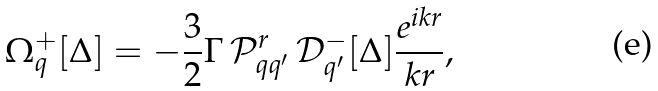<formula> <loc_0><loc_0><loc_500><loc_500>\Omega ^ { + } _ { q } [ \Delta ] = - \frac { 3 } { 2 } \Gamma \, \mathcal { P } ^ { r } _ { q q ^ { \prime } } \, \mathcal { D } ^ { - } _ { q ^ { \prime } } [ \Delta ] \frac { e ^ { i k r } } { k r } ,</formula> 